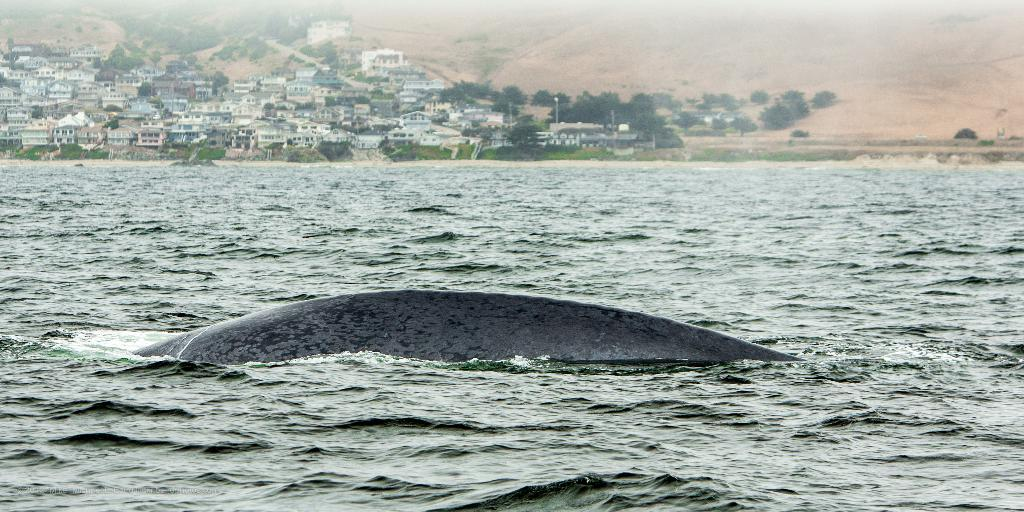What is in the water in the image? There is a fish in the water in the image. What can be seen in the distance in the image? There are buildings, trees, and a hill in the background of the image. How many eggs are sitting on the chairs in the image? There are no eggs or chairs present in the image. 